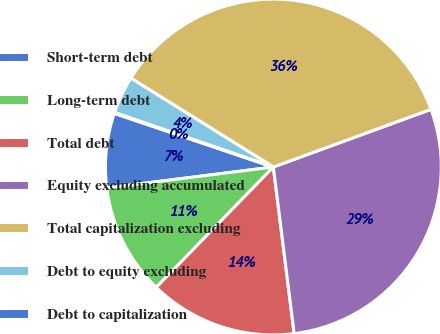Convert chart to OTSL. <chart><loc_0><loc_0><loc_500><loc_500><pie_chart><fcel>Short-term debt<fcel>Long-term debt<fcel>Total debt<fcel>Equity excluding accumulated<fcel>Total capitalization excluding<fcel>Debt to equity excluding<fcel>Debt to capitalization<nl><fcel>7.17%<fcel>10.72%<fcel>14.26%<fcel>28.6%<fcel>35.54%<fcel>3.62%<fcel>0.08%<nl></chart> 